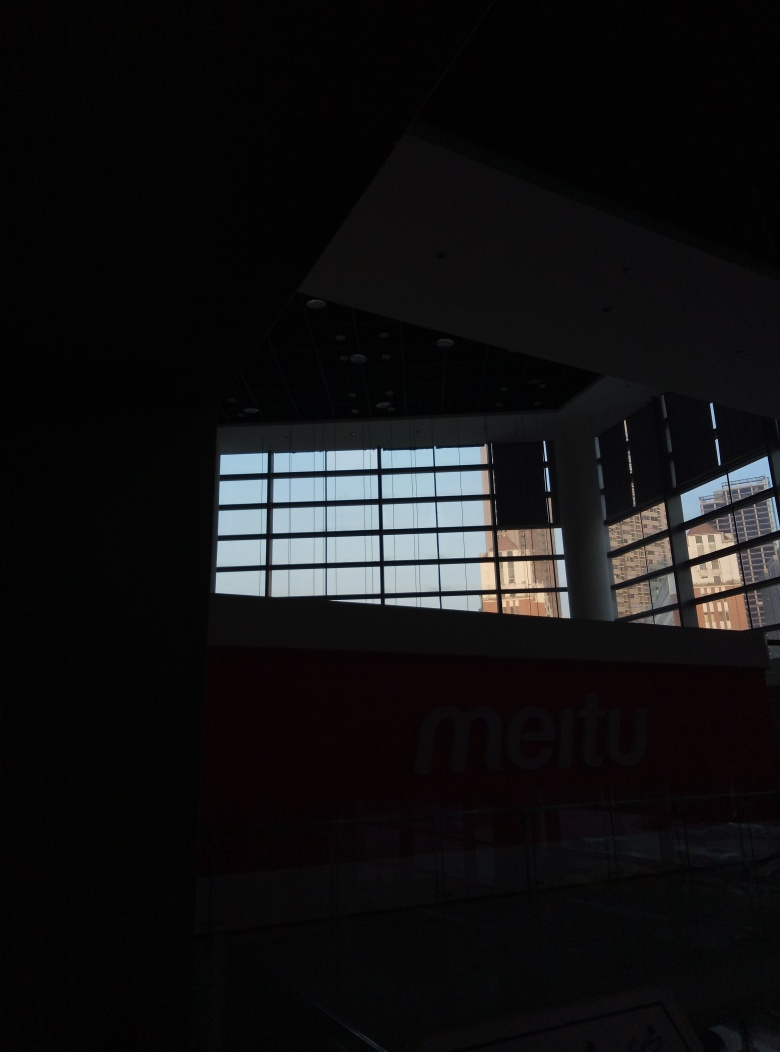Is the indoor space designed for a specific purpose, or is it versatile for various activities? Without additional context or signage that is legible, it is hard to determine a specific purpose for the indoor space. However, it seems to be a large open area with potential for hosting versatile activities, possibly a lobby or concourse due to the expansive layout and the presence of what appears to be a signage or company name in the image. 